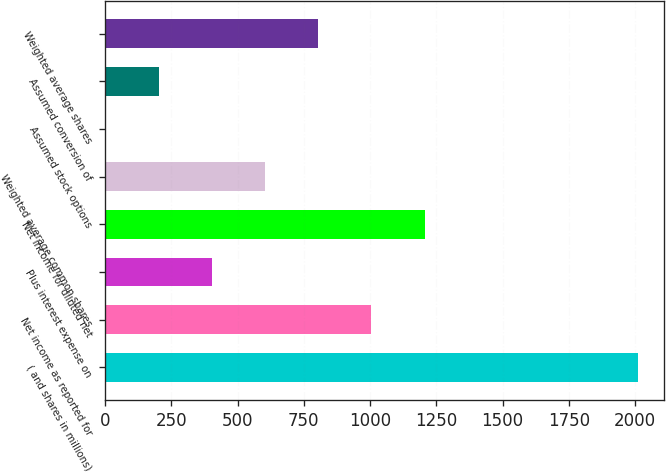<chart> <loc_0><loc_0><loc_500><loc_500><bar_chart><fcel>( and shares in millions)<fcel>Net income as reported for<fcel>Plus interest expense on<fcel>Net income for diluted net<fcel>Weighted average common shares<fcel>Assumed stock options<fcel>Assumed conversion of<fcel>Weighted average shares<nl><fcel>2010<fcel>1005.25<fcel>402.4<fcel>1206.2<fcel>603.35<fcel>0.5<fcel>201.45<fcel>804.3<nl></chart> 